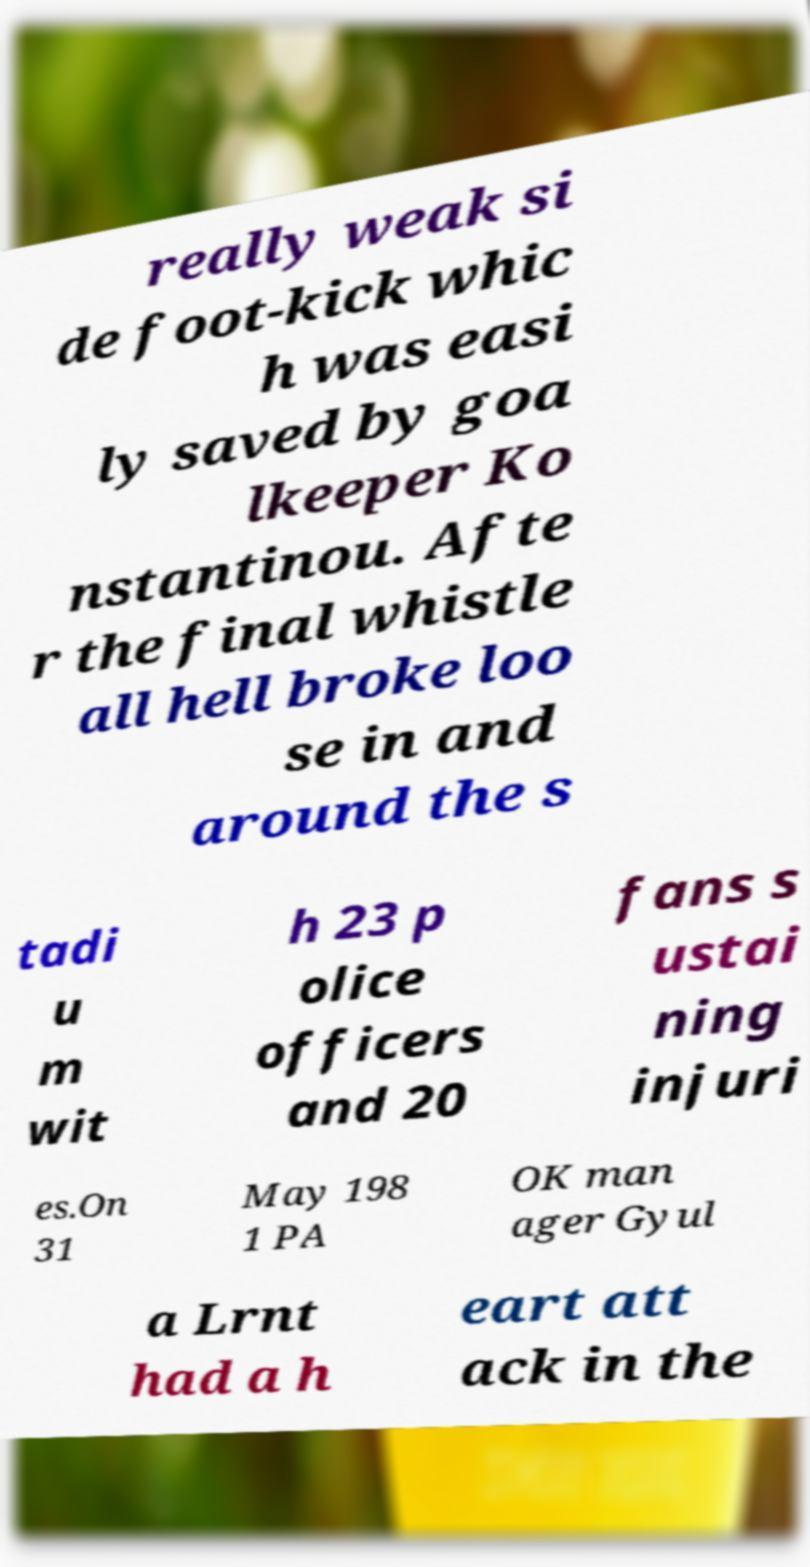For documentation purposes, I need the text within this image transcribed. Could you provide that? really weak si de foot-kick whic h was easi ly saved by goa lkeeper Ko nstantinou. Afte r the final whistle all hell broke loo se in and around the s tadi u m wit h 23 p olice officers and 20 fans s ustai ning injuri es.On 31 May 198 1 PA OK man ager Gyul a Lrnt had a h eart att ack in the 